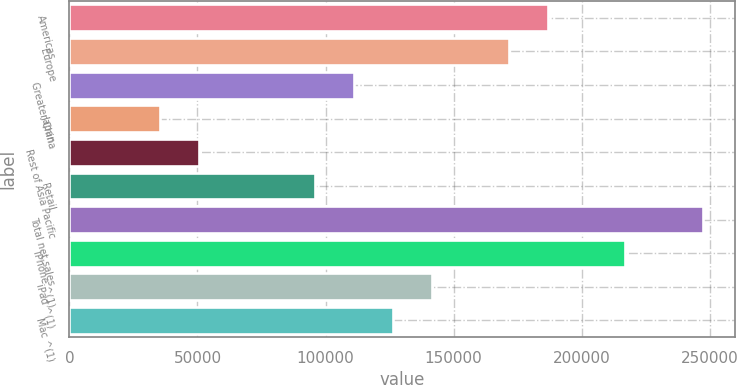Convert chart to OTSL. <chart><loc_0><loc_0><loc_500><loc_500><bar_chart><fcel>Americas<fcel>Europe<fcel>Greater China<fcel>Japan<fcel>Rest of Asia Pacific<fcel>Retail<fcel>Total net sales<fcel>iPhone ^(1)<fcel>iPad ^(1)<fcel>Mac ^(1)<nl><fcel>186781<fcel>171644<fcel>111099<fcel>35417.6<fcel>50553.9<fcel>95962.8<fcel>247326<fcel>217053<fcel>141372<fcel>126235<nl></chart> 